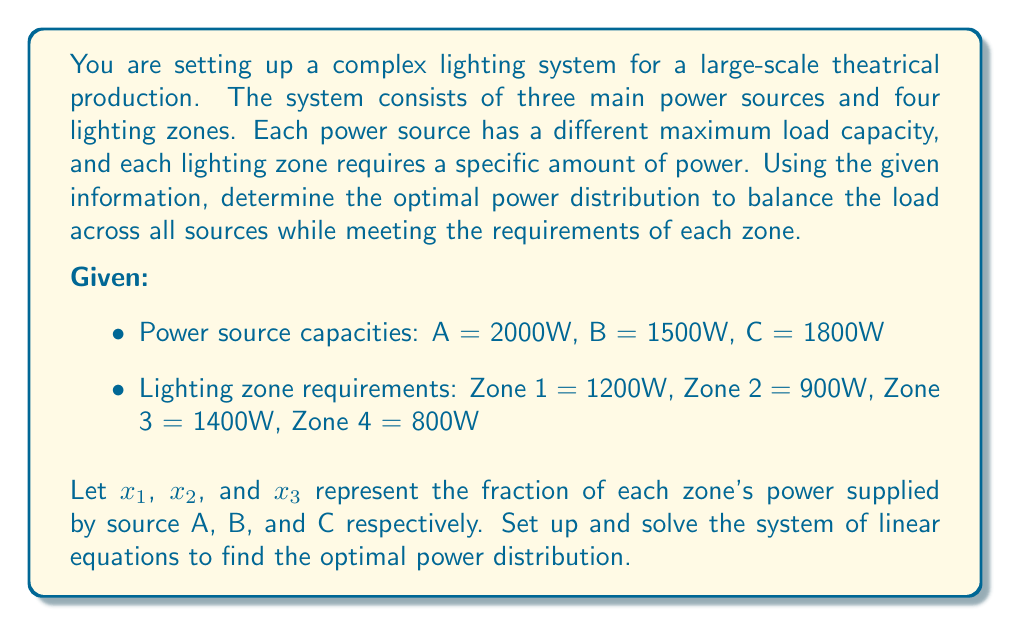Give your solution to this math problem. To solve this problem, we need to set up a system of linear equations based on the given information. We'll use the variables $x_1$, $x_2$, and $x_3$ to represent the fraction of power supplied by sources A, B, and C respectively.

Step 1: Set up the equations
For each lighting zone, the sum of power fractions must equal 1:
$$ x_1 + x_2 + x_3 = 1 $$

For each power source, the total power supplied must not exceed its capacity:

Source A: $$ 1200x_1 + 900x_1 + 1400x_1 + 800x_1 \leq 2000 $$
Source B: $$ 1200x_2 + 900x_2 + 1400x_2 + 800x_2 \leq 1500 $$
Source C: $$ 1200x_3 + 900x_3 + 1400x_3 + 800x_3 \leq 1800 $$

Step 2: Simplify the inequalities
$$ 4300x_1 \leq 2000 $$
$$ 4300x_2 \leq 1500 $$
$$ 4300x_3 \leq 1800 $$

Step 3: Convert inequalities to equations for optimal distribution
$$ 4300x_1 = 2000 $$
$$ 4300x_2 = 1500 $$
$$ 4300x_3 = 1800 $$

Step 4: Solve the system of equations
$$ x_1 = \frac{2000}{4300} \approx 0.4651 $$
$$ x_2 = \frac{1500}{4300} \approx 0.3488 $$
$$ x_3 = \frac{1800}{4300} \approx 0.4186 $$

Step 5: Verify the solution
Sum of fractions: $0.4651 + 0.3488 + 0.4186 = 1.2325$

Since the sum is greater than 1, we need to normalize the fractions:

$$ x_1 = \frac{0.4651}{1.2325} \approx 0.3773 $$
$$ x_2 = \frac{0.3488}{1.2325} \approx 0.2829 $$
$$ x_3 = \frac{0.4186}{1.2325} \approx 0.3397 $$

Step 6: Calculate the power distribution for each zone
Zone 1: $1200 \times (0.3773, 0.2829, 0.3397) = (452.76, 339.48, 407.64)$ W
Zone 2: $900 \times (0.3773, 0.2829, 0.3397) = (339.57, 254.61, 305.73)$ W
Zone 3: $1400 \times (0.3773, 0.2829, 0.3397) = (528.22, 396.06, 475.58)$ W
Zone 4: $800 \times (0.3773, 0.2829, 0.3397) = (301.84, 226.32, 271.76)$ W

Step 7: Verify the total power for each source
Source A: $452.76 + 339.57 + 528.22 + 301.84 = 1622.39$ W
Source B: $339.48 + 254.61 + 396.06 + 226.32 = 1216.47$ W
Source C: $407.64 + 305.73 + 475.58 + 271.76 = 1460.71$ W

All sources are within their capacity limits, and all zones receive their required power.
Answer: $(0.3773, 0.2829, 0.3397)$ 